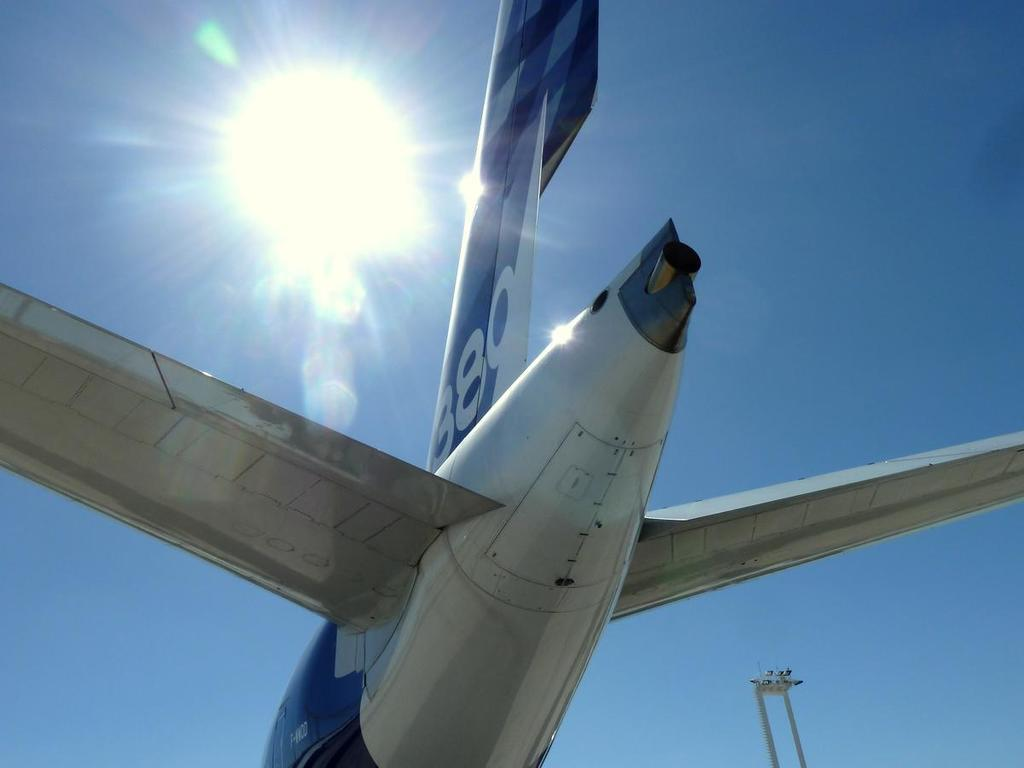Provide a one-sentence caption for the provided image. A tail of a airplane with the number 880 is in the foreground with the sun behind it in the sky. 